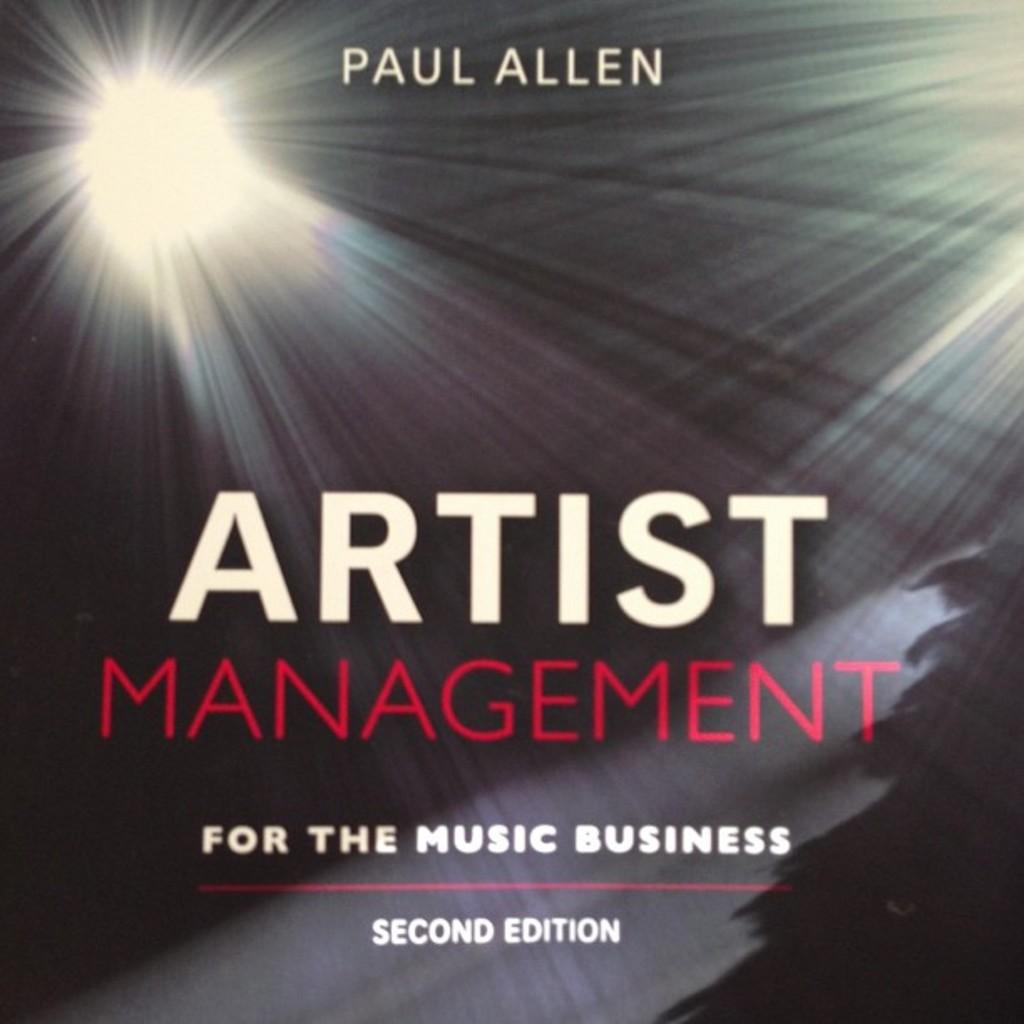<image>
Render a clear and concise summary of the photo. Paul Allen wrote a book on Artist Management or the music business. 